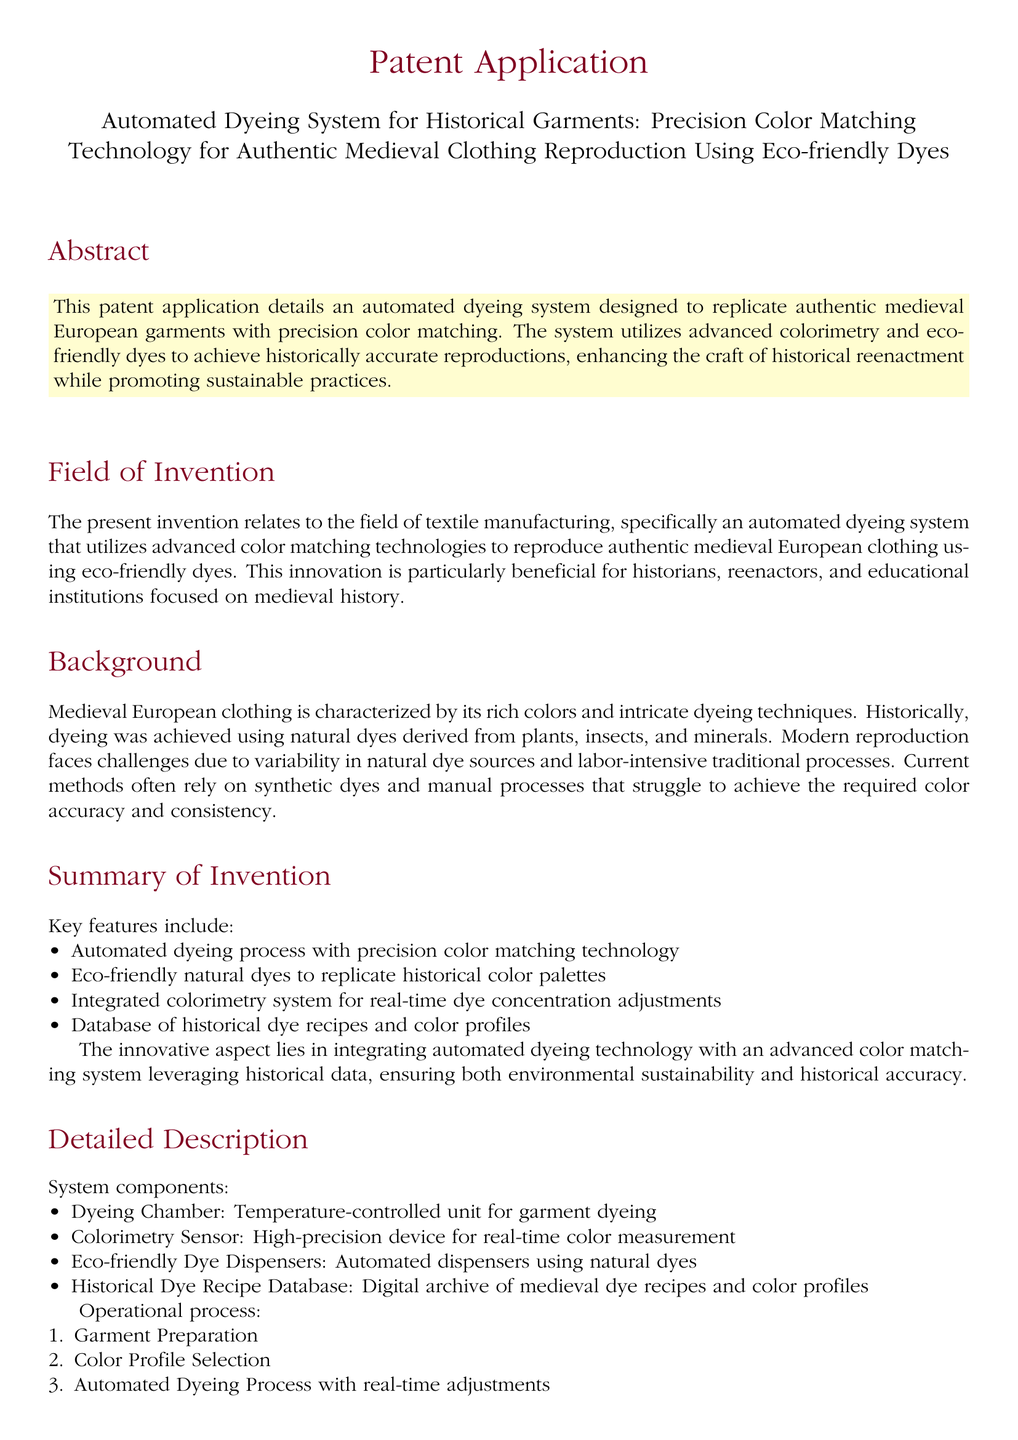What is the title of the patent application? The title of the patent application appears prominently at the beginning of the document.
Answer: Automated Dyeing System for Historical Garments: Precision Color Matching Technology for Authentic Medieval Clothing Reproduction Using Eco-friendly Dyes What year does this invention pertain to? The field of invention mentions a focus on medieval clothing, corresponding to historical time periods.
Answer: Medieval How many key features are listed in the summary of the invention? The number of key features can be determined by counting the items in the bulleted list in the summary.
Answer: Four What system component is used for real-time color measurement? The specific component for color measurement is mentioned in the detailed description section.
Answer: Colorimetry Sensor What is the purpose of the eco-friendly dye dispensers? The function of the eco-friendly dye dispensers is explained within the context of the system components.
Answer: Automated dispensers using natural dyes What is the first step in the operational process? The operational process outlines a series of steps, with the first step being easily identifiable.
Answer: Garment Preparation 